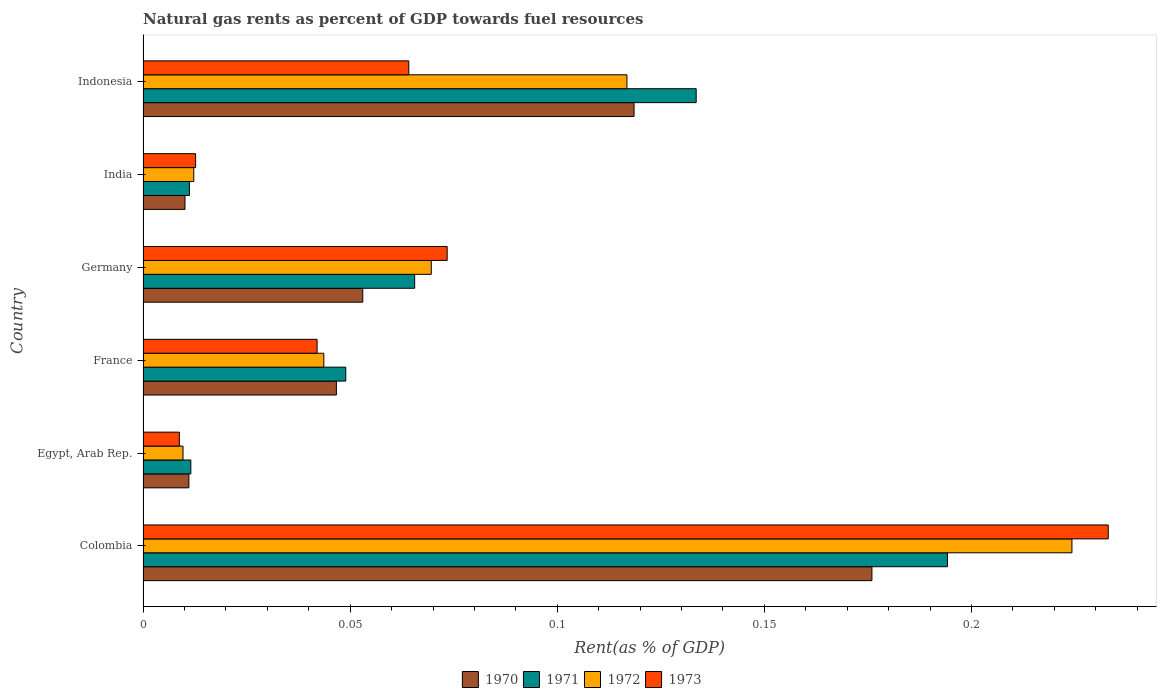How many different coloured bars are there?
Give a very brief answer. 4. Are the number of bars on each tick of the Y-axis equal?
Provide a short and direct response. Yes. How many bars are there on the 1st tick from the top?
Offer a terse response. 4. How many bars are there on the 3rd tick from the bottom?
Keep it short and to the point. 4. In how many cases, is the number of bars for a given country not equal to the number of legend labels?
Your response must be concise. 0. What is the matural gas rent in 1970 in Indonesia?
Your answer should be very brief. 0.12. Across all countries, what is the maximum matural gas rent in 1971?
Provide a succinct answer. 0.19. Across all countries, what is the minimum matural gas rent in 1971?
Ensure brevity in your answer.  0.01. In which country was the matural gas rent in 1972 maximum?
Provide a succinct answer. Colombia. In which country was the matural gas rent in 1970 minimum?
Give a very brief answer. India. What is the total matural gas rent in 1973 in the graph?
Your response must be concise. 0.43. What is the difference between the matural gas rent in 1973 in France and that in Indonesia?
Your answer should be very brief. -0.02. What is the difference between the matural gas rent in 1972 in Colombia and the matural gas rent in 1971 in France?
Ensure brevity in your answer.  0.18. What is the average matural gas rent in 1973 per country?
Ensure brevity in your answer.  0.07. What is the difference between the matural gas rent in 1971 and matural gas rent in 1973 in France?
Make the answer very short. 0.01. What is the ratio of the matural gas rent in 1972 in Germany to that in India?
Keep it short and to the point. 5.68. What is the difference between the highest and the second highest matural gas rent in 1972?
Ensure brevity in your answer.  0.11. What is the difference between the highest and the lowest matural gas rent in 1971?
Provide a succinct answer. 0.18. In how many countries, is the matural gas rent in 1970 greater than the average matural gas rent in 1970 taken over all countries?
Your answer should be compact. 2. Is the sum of the matural gas rent in 1971 in Germany and India greater than the maximum matural gas rent in 1973 across all countries?
Ensure brevity in your answer.  No. Is it the case that in every country, the sum of the matural gas rent in 1972 and matural gas rent in 1970 is greater than the sum of matural gas rent in 1973 and matural gas rent in 1971?
Offer a very short reply. No. Are all the bars in the graph horizontal?
Your response must be concise. Yes. What is the difference between two consecutive major ticks on the X-axis?
Make the answer very short. 0.05. Where does the legend appear in the graph?
Make the answer very short. Bottom center. How many legend labels are there?
Keep it short and to the point. 4. What is the title of the graph?
Make the answer very short. Natural gas rents as percent of GDP towards fuel resources. What is the label or title of the X-axis?
Offer a very short reply. Rent(as % of GDP). What is the label or title of the Y-axis?
Provide a succinct answer. Country. What is the Rent(as % of GDP) in 1970 in Colombia?
Keep it short and to the point. 0.18. What is the Rent(as % of GDP) in 1971 in Colombia?
Your answer should be compact. 0.19. What is the Rent(as % of GDP) in 1972 in Colombia?
Your answer should be very brief. 0.22. What is the Rent(as % of GDP) of 1973 in Colombia?
Provide a short and direct response. 0.23. What is the Rent(as % of GDP) of 1970 in Egypt, Arab Rep.?
Ensure brevity in your answer.  0.01. What is the Rent(as % of GDP) in 1971 in Egypt, Arab Rep.?
Give a very brief answer. 0.01. What is the Rent(as % of GDP) of 1972 in Egypt, Arab Rep.?
Your answer should be very brief. 0.01. What is the Rent(as % of GDP) in 1973 in Egypt, Arab Rep.?
Ensure brevity in your answer.  0.01. What is the Rent(as % of GDP) of 1970 in France?
Offer a terse response. 0.05. What is the Rent(as % of GDP) of 1971 in France?
Keep it short and to the point. 0.05. What is the Rent(as % of GDP) of 1972 in France?
Offer a terse response. 0.04. What is the Rent(as % of GDP) in 1973 in France?
Offer a very short reply. 0.04. What is the Rent(as % of GDP) in 1970 in Germany?
Offer a very short reply. 0.05. What is the Rent(as % of GDP) of 1971 in Germany?
Provide a short and direct response. 0.07. What is the Rent(as % of GDP) of 1972 in Germany?
Your response must be concise. 0.07. What is the Rent(as % of GDP) of 1973 in Germany?
Your answer should be very brief. 0.07. What is the Rent(as % of GDP) of 1970 in India?
Ensure brevity in your answer.  0.01. What is the Rent(as % of GDP) in 1971 in India?
Your answer should be compact. 0.01. What is the Rent(as % of GDP) of 1972 in India?
Your answer should be very brief. 0.01. What is the Rent(as % of GDP) of 1973 in India?
Your answer should be compact. 0.01. What is the Rent(as % of GDP) in 1970 in Indonesia?
Your response must be concise. 0.12. What is the Rent(as % of GDP) in 1971 in Indonesia?
Your answer should be compact. 0.13. What is the Rent(as % of GDP) in 1972 in Indonesia?
Ensure brevity in your answer.  0.12. What is the Rent(as % of GDP) of 1973 in Indonesia?
Make the answer very short. 0.06. Across all countries, what is the maximum Rent(as % of GDP) of 1970?
Your response must be concise. 0.18. Across all countries, what is the maximum Rent(as % of GDP) in 1971?
Offer a very short reply. 0.19. Across all countries, what is the maximum Rent(as % of GDP) in 1972?
Provide a short and direct response. 0.22. Across all countries, what is the maximum Rent(as % of GDP) in 1973?
Your answer should be very brief. 0.23. Across all countries, what is the minimum Rent(as % of GDP) in 1970?
Your answer should be compact. 0.01. Across all countries, what is the minimum Rent(as % of GDP) in 1971?
Offer a very short reply. 0.01. Across all countries, what is the minimum Rent(as % of GDP) of 1972?
Offer a terse response. 0.01. Across all countries, what is the minimum Rent(as % of GDP) in 1973?
Your response must be concise. 0.01. What is the total Rent(as % of GDP) of 1970 in the graph?
Keep it short and to the point. 0.42. What is the total Rent(as % of GDP) of 1971 in the graph?
Make the answer very short. 0.47. What is the total Rent(as % of GDP) in 1972 in the graph?
Make the answer very short. 0.48. What is the total Rent(as % of GDP) in 1973 in the graph?
Provide a short and direct response. 0.43. What is the difference between the Rent(as % of GDP) in 1970 in Colombia and that in Egypt, Arab Rep.?
Provide a short and direct response. 0.16. What is the difference between the Rent(as % of GDP) of 1971 in Colombia and that in Egypt, Arab Rep.?
Your answer should be very brief. 0.18. What is the difference between the Rent(as % of GDP) of 1972 in Colombia and that in Egypt, Arab Rep.?
Give a very brief answer. 0.21. What is the difference between the Rent(as % of GDP) in 1973 in Colombia and that in Egypt, Arab Rep.?
Your answer should be compact. 0.22. What is the difference between the Rent(as % of GDP) in 1970 in Colombia and that in France?
Give a very brief answer. 0.13. What is the difference between the Rent(as % of GDP) in 1971 in Colombia and that in France?
Your response must be concise. 0.15. What is the difference between the Rent(as % of GDP) of 1972 in Colombia and that in France?
Provide a succinct answer. 0.18. What is the difference between the Rent(as % of GDP) of 1973 in Colombia and that in France?
Provide a succinct answer. 0.19. What is the difference between the Rent(as % of GDP) in 1970 in Colombia and that in Germany?
Make the answer very short. 0.12. What is the difference between the Rent(as % of GDP) in 1971 in Colombia and that in Germany?
Offer a terse response. 0.13. What is the difference between the Rent(as % of GDP) of 1972 in Colombia and that in Germany?
Your response must be concise. 0.15. What is the difference between the Rent(as % of GDP) of 1973 in Colombia and that in Germany?
Make the answer very short. 0.16. What is the difference between the Rent(as % of GDP) of 1970 in Colombia and that in India?
Give a very brief answer. 0.17. What is the difference between the Rent(as % of GDP) in 1971 in Colombia and that in India?
Offer a very short reply. 0.18. What is the difference between the Rent(as % of GDP) of 1972 in Colombia and that in India?
Your answer should be compact. 0.21. What is the difference between the Rent(as % of GDP) of 1973 in Colombia and that in India?
Offer a very short reply. 0.22. What is the difference between the Rent(as % of GDP) of 1970 in Colombia and that in Indonesia?
Your answer should be compact. 0.06. What is the difference between the Rent(as % of GDP) of 1971 in Colombia and that in Indonesia?
Offer a very short reply. 0.06. What is the difference between the Rent(as % of GDP) of 1972 in Colombia and that in Indonesia?
Provide a succinct answer. 0.11. What is the difference between the Rent(as % of GDP) in 1973 in Colombia and that in Indonesia?
Keep it short and to the point. 0.17. What is the difference between the Rent(as % of GDP) in 1970 in Egypt, Arab Rep. and that in France?
Your answer should be very brief. -0.04. What is the difference between the Rent(as % of GDP) in 1971 in Egypt, Arab Rep. and that in France?
Your answer should be very brief. -0.04. What is the difference between the Rent(as % of GDP) in 1972 in Egypt, Arab Rep. and that in France?
Your answer should be very brief. -0.03. What is the difference between the Rent(as % of GDP) of 1973 in Egypt, Arab Rep. and that in France?
Offer a terse response. -0.03. What is the difference between the Rent(as % of GDP) in 1970 in Egypt, Arab Rep. and that in Germany?
Provide a succinct answer. -0.04. What is the difference between the Rent(as % of GDP) in 1971 in Egypt, Arab Rep. and that in Germany?
Your answer should be compact. -0.05. What is the difference between the Rent(as % of GDP) in 1972 in Egypt, Arab Rep. and that in Germany?
Ensure brevity in your answer.  -0.06. What is the difference between the Rent(as % of GDP) in 1973 in Egypt, Arab Rep. and that in Germany?
Provide a succinct answer. -0.06. What is the difference between the Rent(as % of GDP) in 1970 in Egypt, Arab Rep. and that in India?
Give a very brief answer. 0. What is the difference between the Rent(as % of GDP) in 1971 in Egypt, Arab Rep. and that in India?
Your answer should be very brief. 0. What is the difference between the Rent(as % of GDP) of 1972 in Egypt, Arab Rep. and that in India?
Provide a short and direct response. -0. What is the difference between the Rent(as % of GDP) in 1973 in Egypt, Arab Rep. and that in India?
Ensure brevity in your answer.  -0. What is the difference between the Rent(as % of GDP) of 1970 in Egypt, Arab Rep. and that in Indonesia?
Keep it short and to the point. -0.11. What is the difference between the Rent(as % of GDP) of 1971 in Egypt, Arab Rep. and that in Indonesia?
Offer a terse response. -0.12. What is the difference between the Rent(as % of GDP) of 1972 in Egypt, Arab Rep. and that in Indonesia?
Make the answer very short. -0.11. What is the difference between the Rent(as % of GDP) in 1973 in Egypt, Arab Rep. and that in Indonesia?
Offer a very short reply. -0.06. What is the difference between the Rent(as % of GDP) of 1970 in France and that in Germany?
Offer a very short reply. -0.01. What is the difference between the Rent(as % of GDP) in 1971 in France and that in Germany?
Provide a short and direct response. -0.02. What is the difference between the Rent(as % of GDP) in 1972 in France and that in Germany?
Provide a short and direct response. -0.03. What is the difference between the Rent(as % of GDP) of 1973 in France and that in Germany?
Keep it short and to the point. -0.03. What is the difference between the Rent(as % of GDP) in 1970 in France and that in India?
Offer a very short reply. 0.04. What is the difference between the Rent(as % of GDP) of 1971 in France and that in India?
Provide a succinct answer. 0.04. What is the difference between the Rent(as % of GDP) in 1972 in France and that in India?
Ensure brevity in your answer.  0.03. What is the difference between the Rent(as % of GDP) in 1973 in France and that in India?
Provide a succinct answer. 0.03. What is the difference between the Rent(as % of GDP) in 1970 in France and that in Indonesia?
Your answer should be very brief. -0.07. What is the difference between the Rent(as % of GDP) in 1971 in France and that in Indonesia?
Ensure brevity in your answer.  -0.08. What is the difference between the Rent(as % of GDP) of 1972 in France and that in Indonesia?
Your response must be concise. -0.07. What is the difference between the Rent(as % of GDP) in 1973 in France and that in Indonesia?
Keep it short and to the point. -0.02. What is the difference between the Rent(as % of GDP) in 1970 in Germany and that in India?
Give a very brief answer. 0.04. What is the difference between the Rent(as % of GDP) of 1971 in Germany and that in India?
Give a very brief answer. 0.05. What is the difference between the Rent(as % of GDP) in 1972 in Germany and that in India?
Your response must be concise. 0.06. What is the difference between the Rent(as % of GDP) of 1973 in Germany and that in India?
Your response must be concise. 0.06. What is the difference between the Rent(as % of GDP) in 1970 in Germany and that in Indonesia?
Offer a terse response. -0.07. What is the difference between the Rent(as % of GDP) of 1971 in Germany and that in Indonesia?
Offer a very short reply. -0.07. What is the difference between the Rent(as % of GDP) in 1972 in Germany and that in Indonesia?
Ensure brevity in your answer.  -0.05. What is the difference between the Rent(as % of GDP) of 1973 in Germany and that in Indonesia?
Provide a succinct answer. 0.01. What is the difference between the Rent(as % of GDP) in 1970 in India and that in Indonesia?
Offer a terse response. -0.11. What is the difference between the Rent(as % of GDP) of 1971 in India and that in Indonesia?
Ensure brevity in your answer.  -0.12. What is the difference between the Rent(as % of GDP) in 1972 in India and that in Indonesia?
Provide a succinct answer. -0.1. What is the difference between the Rent(as % of GDP) of 1973 in India and that in Indonesia?
Your answer should be very brief. -0.05. What is the difference between the Rent(as % of GDP) in 1970 in Colombia and the Rent(as % of GDP) in 1971 in Egypt, Arab Rep.?
Offer a terse response. 0.16. What is the difference between the Rent(as % of GDP) in 1970 in Colombia and the Rent(as % of GDP) in 1972 in Egypt, Arab Rep.?
Make the answer very short. 0.17. What is the difference between the Rent(as % of GDP) in 1970 in Colombia and the Rent(as % of GDP) in 1973 in Egypt, Arab Rep.?
Provide a succinct answer. 0.17. What is the difference between the Rent(as % of GDP) in 1971 in Colombia and the Rent(as % of GDP) in 1972 in Egypt, Arab Rep.?
Offer a terse response. 0.18. What is the difference between the Rent(as % of GDP) in 1971 in Colombia and the Rent(as % of GDP) in 1973 in Egypt, Arab Rep.?
Keep it short and to the point. 0.19. What is the difference between the Rent(as % of GDP) in 1972 in Colombia and the Rent(as % of GDP) in 1973 in Egypt, Arab Rep.?
Your response must be concise. 0.22. What is the difference between the Rent(as % of GDP) of 1970 in Colombia and the Rent(as % of GDP) of 1971 in France?
Provide a short and direct response. 0.13. What is the difference between the Rent(as % of GDP) in 1970 in Colombia and the Rent(as % of GDP) in 1972 in France?
Ensure brevity in your answer.  0.13. What is the difference between the Rent(as % of GDP) in 1970 in Colombia and the Rent(as % of GDP) in 1973 in France?
Provide a succinct answer. 0.13. What is the difference between the Rent(as % of GDP) of 1971 in Colombia and the Rent(as % of GDP) of 1972 in France?
Your answer should be compact. 0.15. What is the difference between the Rent(as % of GDP) of 1971 in Colombia and the Rent(as % of GDP) of 1973 in France?
Offer a very short reply. 0.15. What is the difference between the Rent(as % of GDP) of 1972 in Colombia and the Rent(as % of GDP) of 1973 in France?
Give a very brief answer. 0.18. What is the difference between the Rent(as % of GDP) in 1970 in Colombia and the Rent(as % of GDP) in 1971 in Germany?
Provide a succinct answer. 0.11. What is the difference between the Rent(as % of GDP) in 1970 in Colombia and the Rent(as % of GDP) in 1972 in Germany?
Keep it short and to the point. 0.11. What is the difference between the Rent(as % of GDP) of 1970 in Colombia and the Rent(as % of GDP) of 1973 in Germany?
Ensure brevity in your answer.  0.1. What is the difference between the Rent(as % of GDP) of 1971 in Colombia and the Rent(as % of GDP) of 1972 in Germany?
Offer a very short reply. 0.12. What is the difference between the Rent(as % of GDP) of 1971 in Colombia and the Rent(as % of GDP) of 1973 in Germany?
Ensure brevity in your answer.  0.12. What is the difference between the Rent(as % of GDP) of 1972 in Colombia and the Rent(as % of GDP) of 1973 in Germany?
Provide a short and direct response. 0.15. What is the difference between the Rent(as % of GDP) in 1970 in Colombia and the Rent(as % of GDP) in 1971 in India?
Provide a short and direct response. 0.16. What is the difference between the Rent(as % of GDP) of 1970 in Colombia and the Rent(as % of GDP) of 1972 in India?
Ensure brevity in your answer.  0.16. What is the difference between the Rent(as % of GDP) of 1970 in Colombia and the Rent(as % of GDP) of 1973 in India?
Make the answer very short. 0.16. What is the difference between the Rent(as % of GDP) of 1971 in Colombia and the Rent(as % of GDP) of 1972 in India?
Give a very brief answer. 0.18. What is the difference between the Rent(as % of GDP) of 1971 in Colombia and the Rent(as % of GDP) of 1973 in India?
Provide a short and direct response. 0.18. What is the difference between the Rent(as % of GDP) of 1972 in Colombia and the Rent(as % of GDP) of 1973 in India?
Your answer should be very brief. 0.21. What is the difference between the Rent(as % of GDP) of 1970 in Colombia and the Rent(as % of GDP) of 1971 in Indonesia?
Ensure brevity in your answer.  0.04. What is the difference between the Rent(as % of GDP) of 1970 in Colombia and the Rent(as % of GDP) of 1972 in Indonesia?
Offer a terse response. 0.06. What is the difference between the Rent(as % of GDP) in 1970 in Colombia and the Rent(as % of GDP) in 1973 in Indonesia?
Make the answer very short. 0.11. What is the difference between the Rent(as % of GDP) of 1971 in Colombia and the Rent(as % of GDP) of 1972 in Indonesia?
Offer a very short reply. 0.08. What is the difference between the Rent(as % of GDP) of 1971 in Colombia and the Rent(as % of GDP) of 1973 in Indonesia?
Keep it short and to the point. 0.13. What is the difference between the Rent(as % of GDP) in 1972 in Colombia and the Rent(as % of GDP) in 1973 in Indonesia?
Your response must be concise. 0.16. What is the difference between the Rent(as % of GDP) of 1970 in Egypt, Arab Rep. and the Rent(as % of GDP) of 1971 in France?
Provide a succinct answer. -0.04. What is the difference between the Rent(as % of GDP) in 1970 in Egypt, Arab Rep. and the Rent(as % of GDP) in 1972 in France?
Your answer should be very brief. -0.03. What is the difference between the Rent(as % of GDP) in 1970 in Egypt, Arab Rep. and the Rent(as % of GDP) in 1973 in France?
Keep it short and to the point. -0.03. What is the difference between the Rent(as % of GDP) of 1971 in Egypt, Arab Rep. and the Rent(as % of GDP) of 1972 in France?
Your answer should be very brief. -0.03. What is the difference between the Rent(as % of GDP) in 1971 in Egypt, Arab Rep. and the Rent(as % of GDP) in 1973 in France?
Ensure brevity in your answer.  -0.03. What is the difference between the Rent(as % of GDP) in 1972 in Egypt, Arab Rep. and the Rent(as % of GDP) in 1973 in France?
Provide a short and direct response. -0.03. What is the difference between the Rent(as % of GDP) of 1970 in Egypt, Arab Rep. and the Rent(as % of GDP) of 1971 in Germany?
Provide a short and direct response. -0.05. What is the difference between the Rent(as % of GDP) of 1970 in Egypt, Arab Rep. and the Rent(as % of GDP) of 1972 in Germany?
Provide a short and direct response. -0.06. What is the difference between the Rent(as % of GDP) in 1970 in Egypt, Arab Rep. and the Rent(as % of GDP) in 1973 in Germany?
Your response must be concise. -0.06. What is the difference between the Rent(as % of GDP) of 1971 in Egypt, Arab Rep. and the Rent(as % of GDP) of 1972 in Germany?
Make the answer very short. -0.06. What is the difference between the Rent(as % of GDP) in 1971 in Egypt, Arab Rep. and the Rent(as % of GDP) in 1973 in Germany?
Offer a terse response. -0.06. What is the difference between the Rent(as % of GDP) in 1972 in Egypt, Arab Rep. and the Rent(as % of GDP) in 1973 in Germany?
Give a very brief answer. -0.06. What is the difference between the Rent(as % of GDP) of 1970 in Egypt, Arab Rep. and the Rent(as % of GDP) of 1971 in India?
Give a very brief answer. -0. What is the difference between the Rent(as % of GDP) in 1970 in Egypt, Arab Rep. and the Rent(as % of GDP) in 1972 in India?
Make the answer very short. -0. What is the difference between the Rent(as % of GDP) in 1970 in Egypt, Arab Rep. and the Rent(as % of GDP) in 1973 in India?
Offer a terse response. -0. What is the difference between the Rent(as % of GDP) of 1971 in Egypt, Arab Rep. and the Rent(as % of GDP) of 1972 in India?
Your response must be concise. -0. What is the difference between the Rent(as % of GDP) of 1971 in Egypt, Arab Rep. and the Rent(as % of GDP) of 1973 in India?
Provide a succinct answer. -0. What is the difference between the Rent(as % of GDP) in 1972 in Egypt, Arab Rep. and the Rent(as % of GDP) in 1973 in India?
Your answer should be very brief. -0. What is the difference between the Rent(as % of GDP) of 1970 in Egypt, Arab Rep. and the Rent(as % of GDP) of 1971 in Indonesia?
Your answer should be very brief. -0.12. What is the difference between the Rent(as % of GDP) in 1970 in Egypt, Arab Rep. and the Rent(as % of GDP) in 1972 in Indonesia?
Offer a very short reply. -0.11. What is the difference between the Rent(as % of GDP) in 1970 in Egypt, Arab Rep. and the Rent(as % of GDP) in 1973 in Indonesia?
Your answer should be very brief. -0.05. What is the difference between the Rent(as % of GDP) of 1971 in Egypt, Arab Rep. and the Rent(as % of GDP) of 1972 in Indonesia?
Your answer should be very brief. -0.11. What is the difference between the Rent(as % of GDP) in 1971 in Egypt, Arab Rep. and the Rent(as % of GDP) in 1973 in Indonesia?
Give a very brief answer. -0.05. What is the difference between the Rent(as % of GDP) in 1972 in Egypt, Arab Rep. and the Rent(as % of GDP) in 1973 in Indonesia?
Provide a short and direct response. -0.05. What is the difference between the Rent(as % of GDP) in 1970 in France and the Rent(as % of GDP) in 1971 in Germany?
Keep it short and to the point. -0.02. What is the difference between the Rent(as % of GDP) in 1970 in France and the Rent(as % of GDP) in 1972 in Germany?
Your answer should be very brief. -0.02. What is the difference between the Rent(as % of GDP) of 1970 in France and the Rent(as % of GDP) of 1973 in Germany?
Your answer should be very brief. -0.03. What is the difference between the Rent(as % of GDP) in 1971 in France and the Rent(as % of GDP) in 1972 in Germany?
Your answer should be compact. -0.02. What is the difference between the Rent(as % of GDP) in 1971 in France and the Rent(as % of GDP) in 1973 in Germany?
Provide a short and direct response. -0.02. What is the difference between the Rent(as % of GDP) in 1972 in France and the Rent(as % of GDP) in 1973 in Germany?
Your response must be concise. -0.03. What is the difference between the Rent(as % of GDP) of 1970 in France and the Rent(as % of GDP) of 1971 in India?
Provide a short and direct response. 0.04. What is the difference between the Rent(as % of GDP) of 1970 in France and the Rent(as % of GDP) of 1972 in India?
Give a very brief answer. 0.03. What is the difference between the Rent(as % of GDP) in 1970 in France and the Rent(as % of GDP) in 1973 in India?
Provide a short and direct response. 0.03. What is the difference between the Rent(as % of GDP) of 1971 in France and the Rent(as % of GDP) of 1972 in India?
Make the answer very short. 0.04. What is the difference between the Rent(as % of GDP) of 1971 in France and the Rent(as % of GDP) of 1973 in India?
Give a very brief answer. 0.04. What is the difference between the Rent(as % of GDP) in 1972 in France and the Rent(as % of GDP) in 1973 in India?
Your answer should be compact. 0.03. What is the difference between the Rent(as % of GDP) of 1970 in France and the Rent(as % of GDP) of 1971 in Indonesia?
Your answer should be very brief. -0.09. What is the difference between the Rent(as % of GDP) of 1970 in France and the Rent(as % of GDP) of 1972 in Indonesia?
Make the answer very short. -0.07. What is the difference between the Rent(as % of GDP) of 1970 in France and the Rent(as % of GDP) of 1973 in Indonesia?
Keep it short and to the point. -0.02. What is the difference between the Rent(as % of GDP) in 1971 in France and the Rent(as % of GDP) in 1972 in Indonesia?
Provide a succinct answer. -0.07. What is the difference between the Rent(as % of GDP) of 1971 in France and the Rent(as % of GDP) of 1973 in Indonesia?
Ensure brevity in your answer.  -0.02. What is the difference between the Rent(as % of GDP) of 1972 in France and the Rent(as % of GDP) of 1973 in Indonesia?
Provide a succinct answer. -0.02. What is the difference between the Rent(as % of GDP) of 1970 in Germany and the Rent(as % of GDP) of 1971 in India?
Give a very brief answer. 0.04. What is the difference between the Rent(as % of GDP) in 1970 in Germany and the Rent(as % of GDP) in 1972 in India?
Your answer should be very brief. 0.04. What is the difference between the Rent(as % of GDP) in 1970 in Germany and the Rent(as % of GDP) in 1973 in India?
Offer a terse response. 0.04. What is the difference between the Rent(as % of GDP) of 1971 in Germany and the Rent(as % of GDP) of 1972 in India?
Provide a short and direct response. 0.05. What is the difference between the Rent(as % of GDP) in 1971 in Germany and the Rent(as % of GDP) in 1973 in India?
Your response must be concise. 0.05. What is the difference between the Rent(as % of GDP) of 1972 in Germany and the Rent(as % of GDP) of 1973 in India?
Make the answer very short. 0.06. What is the difference between the Rent(as % of GDP) in 1970 in Germany and the Rent(as % of GDP) in 1971 in Indonesia?
Provide a short and direct response. -0.08. What is the difference between the Rent(as % of GDP) in 1970 in Germany and the Rent(as % of GDP) in 1972 in Indonesia?
Your response must be concise. -0.06. What is the difference between the Rent(as % of GDP) of 1970 in Germany and the Rent(as % of GDP) of 1973 in Indonesia?
Keep it short and to the point. -0.01. What is the difference between the Rent(as % of GDP) of 1971 in Germany and the Rent(as % of GDP) of 1972 in Indonesia?
Give a very brief answer. -0.05. What is the difference between the Rent(as % of GDP) of 1971 in Germany and the Rent(as % of GDP) of 1973 in Indonesia?
Make the answer very short. 0. What is the difference between the Rent(as % of GDP) of 1972 in Germany and the Rent(as % of GDP) of 1973 in Indonesia?
Your answer should be very brief. 0.01. What is the difference between the Rent(as % of GDP) in 1970 in India and the Rent(as % of GDP) in 1971 in Indonesia?
Ensure brevity in your answer.  -0.12. What is the difference between the Rent(as % of GDP) in 1970 in India and the Rent(as % of GDP) in 1972 in Indonesia?
Make the answer very short. -0.11. What is the difference between the Rent(as % of GDP) of 1970 in India and the Rent(as % of GDP) of 1973 in Indonesia?
Make the answer very short. -0.05. What is the difference between the Rent(as % of GDP) of 1971 in India and the Rent(as % of GDP) of 1972 in Indonesia?
Offer a terse response. -0.11. What is the difference between the Rent(as % of GDP) of 1971 in India and the Rent(as % of GDP) of 1973 in Indonesia?
Your answer should be compact. -0.05. What is the difference between the Rent(as % of GDP) of 1972 in India and the Rent(as % of GDP) of 1973 in Indonesia?
Provide a succinct answer. -0.05. What is the average Rent(as % of GDP) in 1970 per country?
Your answer should be very brief. 0.07. What is the average Rent(as % of GDP) of 1971 per country?
Provide a succinct answer. 0.08. What is the average Rent(as % of GDP) in 1972 per country?
Provide a succinct answer. 0.08. What is the average Rent(as % of GDP) of 1973 per country?
Make the answer very short. 0.07. What is the difference between the Rent(as % of GDP) in 1970 and Rent(as % of GDP) in 1971 in Colombia?
Offer a terse response. -0.02. What is the difference between the Rent(as % of GDP) in 1970 and Rent(as % of GDP) in 1972 in Colombia?
Give a very brief answer. -0.05. What is the difference between the Rent(as % of GDP) in 1970 and Rent(as % of GDP) in 1973 in Colombia?
Your answer should be very brief. -0.06. What is the difference between the Rent(as % of GDP) of 1971 and Rent(as % of GDP) of 1972 in Colombia?
Make the answer very short. -0.03. What is the difference between the Rent(as % of GDP) of 1971 and Rent(as % of GDP) of 1973 in Colombia?
Keep it short and to the point. -0.04. What is the difference between the Rent(as % of GDP) in 1972 and Rent(as % of GDP) in 1973 in Colombia?
Your response must be concise. -0.01. What is the difference between the Rent(as % of GDP) of 1970 and Rent(as % of GDP) of 1971 in Egypt, Arab Rep.?
Make the answer very short. -0. What is the difference between the Rent(as % of GDP) of 1970 and Rent(as % of GDP) of 1972 in Egypt, Arab Rep.?
Make the answer very short. 0. What is the difference between the Rent(as % of GDP) of 1970 and Rent(as % of GDP) of 1973 in Egypt, Arab Rep.?
Your answer should be compact. 0. What is the difference between the Rent(as % of GDP) in 1971 and Rent(as % of GDP) in 1972 in Egypt, Arab Rep.?
Make the answer very short. 0. What is the difference between the Rent(as % of GDP) of 1971 and Rent(as % of GDP) of 1973 in Egypt, Arab Rep.?
Make the answer very short. 0. What is the difference between the Rent(as % of GDP) of 1972 and Rent(as % of GDP) of 1973 in Egypt, Arab Rep.?
Keep it short and to the point. 0. What is the difference between the Rent(as % of GDP) of 1970 and Rent(as % of GDP) of 1971 in France?
Provide a short and direct response. -0. What is the difference between the Rent(as % of GDP) in 1970 and Rent(as % of GDP) in 1972 in France?
Offer a terse response. 0. What is the difference between the Rent(as % of GDP) in 1970 and Rent(as % of GDP) in 1973 in France?
Keep it short and to the point. 0. What is the difference between the Rent(as % of GDP) of 1971 and Rent(as % of GDP) of 1972 in France?
Offer a very short reply. 0.01. What is the difference between the Rent(as % of GDP) in 1971 and Rent(as % of GDP) in 1973 in France?
Offer a terse response. 0.01. What is the difference between the Rent(as % of GDP) of 1972 and Rent(as % of GDP) of 1973 in France?
Offer a terse response. 0. What is the difference between the Rent(as % of GDP) in 1970 and Rent(as % of GDP) in 1971 in Germany?
Offer a terse response. -0.01. What is the difference between the Rent(as % of GDP) in 1970 and Rent(as % of GDP) in 1972 in Germany?
Provide a succinct answer. -0.02. What is the difference between the Rent(as % of GDP) of 1970 and Rent(as % of GDP) of 1973 in Germany?
Give a very brief answer. -0.02. What is the difference between the Rent(as % of GDP) in 1971 and Rent(as % of GDP) in 1972 in Germany?
Offer a very short reply. -0. What is the difference between the Rent(as % of GDP) in 1971 and Rent(as % of GDP) in 1973 in Germany?
Make the answer very short. -0.01. What is the difference between the Rent(as % of GDP) in 1972 and Rent(as % of GDP) in 1973 in Germany?
Keep it short and to the point. -0. What is the difference between the Rent(as % of GDP) of 1970 and Rent(as % of GDP) of 1971 in India?
Your answer should be compact. -0. What is the difference between the Rent(as % of GDP) of 1970 and Rent(as % of GDP) of 1972 in India?
Ensure brevity in your answer.  -0. What is the difference between the Rent(as % of GDP) of 1970 and Rent(as % of GDP) of 1973 in India?
Ensure brevity in your answer.  -0. What is the difference between the Rent(as % of GDP) in 1971 and Rent(as % of GDP) in 1972 in India?
Offer a very short reply. -0. What is the difference between the Rent(as % of GDP) in 1971 and Rent(as % of GDP) in 1973 in India?
Offer a very short reply. -0. What is the difference between the Rent(as % of GDP) in 1972 and Rent(as % of GDP) in 1973 in India?
Your answer should be compact. -0. What is the difference between the Rent(as % of GDP) of 1970 and Rent(as % of GDP) of 1971 in Indonesia?
Ensure brevity in your answer.  -0.01. What is the difference between the Rent(as % of GDP) of 1970 and Rent(as % of GDP) of 1972 in Indonesia?
Offer a very short reply. 0. What is the difference between the Rent(as % of GDP) of 1970 and Rent(as % of GDP) of 1973 in Indonesia?
Your response must be concise. 0.05. What is the difference between the Rent(as % of GDP) in 1971 and Rent(as % of GDP) in 1972 in Indonesia?
Your answer should be very brief. 0.02. What is the difference between the Rent(as % of GDP) of 1971 and Rent(as % of GDP) of 1973 in Indonesia?
Keep it short and to the point. 0.07. What is the difference between the Rent(as % of GDP) in 1972 and Rent(as % of GDP) in 1973 in Indonesia?
Your answer should be compact. 0.05. What is the ratio of the Rent(as % of GDP) in 1970 in Colombia to that in Egypt, Arab Rep.?
Provide a succinct answer. 15.9. What is the ratio of the Rent(as % of GDP) of 1971 in Colombia to that in Egypt, Arab Rep.?
Ensure brevity in your answer.  16.84. What is the ratio of the Rent(as % of GDP) of 1972 in Colombia to that in Egypt, Arab Rep.?
Give a very brief answer. 23.25. What is the ratio of the Rent(as % of GDP) in 1973 in Colombia to that in Egypt, Arab Rep.?
Your answer should be very brief. 26.6. What is the ratio of the Rent(as % of GDP) of 1970 in Colombia to that in France?
Make the answer very short. 3.77. What is the ratio of the Rent(as % of GDP) of 1971 in Colombia to that in France?
Ensure brevity in your answer.  3.97. What is the ratio of the Rent(as % of GDP) in 1972 in Colombia to that in France?
Your answer should be very brief. 5.14. What is the ratio of the Rent(as % of GDP) of 1973 in Colombia to that in France?
Your answer should be very brief. 5.55. What is the ratio of the Rent(as % of GDP) of 1970 in Colombia to that in Germany?
Offer a terse response. 3.32. What is the ratio of the Rent(as % of GDP) of 1971 in Colombia to that in Germany?
Give a very brief answer. 2.96. What is the ratio of the Rent(as % of GDP) of 1972 in Colombia to that in Germany?
Provide a short and direct response. 3.22. What is the ratio of the Rent(as % of GDP) in 1973 in Colombia to that in Germany?
Your answer should be very brief. 3.17. What is the ratio of the Rent(as % of GDP) in 1970 in Colombia to that in India?
Your answer should be very brief. 17.38. What is the ratio of the Rent(as % of GDP) of 1971 in Colombia to that in India?
Keep it short and to the point. 17.35. What is the ratio of the Rent(as % of GDP) of 1972 in Colombia to that in India?
Give a very brief answer. 18.31. What is the ratio of the Rent(as % of GDP) of 1973 in Colombia to that in India?
Your response must be concise. 18.36. What is the ratio of the Rent(as % of GDP) in 1970 in Colombia to that in Indonesia?
Your answer should be compact. 1.48. What is the ratio of the Rent(as % of GDP) in 1971 in Colombia to that in Indonesia?
Provide a succinct answer. 1.45. What is the ratio of the Rent(as % of GDP) in 1972 in Colombia to that in Indonesia?
Ensure brevity in your answer.  1.92. What is the ratio of the Rent(as % of GDP) in 1973 in Colombia to that in Indonesia?
Provide a succinct answer. 3.63. What is the ratio of the Rent(as % of GDP) of 1970 in Egypt, Arab Rep. to that in France?
Offer a very short reply. 0.24. What is the ratio of the Rent(as % of GDP) of 1971 in Egypt, Arab Rep. to that in France?
Provide a short and direct response. 0.24. What is the ratio of the Rent(as % of GDP) in 1972 in Egypt, Arab Rep. to that in France?
Keep it short and to the point. 0.22. What is the ratio of the Rent(as % of GDP) in 1973 in Egypt, Arab Rep. to that in France?
Offer a very short reply. 0.21. What is the ratio of the Rent(as % of GDP) in 1970 in Egypt, Arab Rep. to that in Germany?
Provide a short and direct response. 0.21. What is the ratio of the Rent(as % of GDP) of 1971 in Egypt, Arab Rep. to that in Germany?
Keep it short and to the point. 0.18. What is the ratio of the Rent(as % of GDP) of 1972 in Egypt, Arab Rep. to that in Germany?
Provide a succinct answer. 0.14. What is the ratio of the Rent(as % of GDP) of 1973 in Egypt, Arab Rep. to that in Germany?
Your answer should be very brief. 0.12. What is the ratio of the Rent(as % of GDP) in 1970 in Egypt, Arab Rep. to that in India?
Ensure brevity in your answer.  1.09. What is the ratio of the Rent(as % of GDP) in 1971 in Egypt, Arab Rep. to that in India?
Your answer should be very brief. 1.03. What is the ratio of the Rent(as % of GDP) in 1972 in Egypt, Arab Rep. to that in India?
Provide a succinct answer. 0.79. What is the ratio of the Rent(as % of GDP) of 1973 in Egypt, Arab Rep. to that in India?
Offer a very short reply. 0.69. What is the ratio of the Rent(as % of GDP) of 1970 in Egypt, Arab Rep. to that in Indonesia?
Your response must be concise. 0.09. What is the ratio of the Rent(as % of GDP) in 1971 in Egypt, Arab Rep. to that in Indonesia?
Offer a terse response. 0.09. What is the ratio of the Rent(as % of GDP) in 1972 in Egypt, Arab Rep. to that in Indonesia?
Your answer should be compact. 0.08. What is the ratio of the Rent(as % of GDP) of 1973 in Egypt, Arab Rep. to that in Indonesia?
Ensure brevity in your answer.  0.14. What is the ratio of the Rent(as % of GDP) of 1970 in France to that in Germany?
Your answer should be compact. 0.88. What is the ratio of the Rent(as % of GDP) of 1971 in France to that in Germany?
Your answer should be compact. 0.75. What is the ratio of the Rent(as % of GDP) in 1972 in France to that in Germany?
Your answer should be compact. 0.63. What is the ratio of the Rent(as % of GDP) of 1973 in France to that in Germany?
Provide a succinct answer. 0.57. What is the ratio of the Rent(as % of GDP) in 1970 in France to that in India?
Offer a very short reply. 4.61. What is the ratio of the Rent(as % of GDP) in 1971 in France to that in India?
Offer a terse response. 4.37. What is the ratio of the Rent(as % of GDP) in 1972 in France to that in India?
Give a very brief answer. 3.56. What is the ratio of the Rent(as % of GDP) in 1973 in France to that in India?
Give a very brief answer. 3.31. What is the ratio of the Rent(as % of GDP) of 1970 in France to that in Indonesia?
Ensure brevity in your answer.  0.39. What is the ratio of the Rent(as % of GDP) of 1971 in France to that in Indonesia?
Provide a succinct answer. 0.37. What is the ratio of the Rent(as % of GDP) in 1972 in France to that in Indonesia?
Your answer should be compact. 0.37. What is the ratio of the Rent(as % of GDP) in 1973 in France to that in Indonesia?
Offer a very short reply. 0.65. What is the ratio of the Rent(as % of GDP) of 1970 in Germany to that in India?
Ensure brevity in your answer.  5.24. What is the ratio of the Rent(as % of GDP) of 1971 in Germany to that in India?
Offer a terse response. 5.86. What is the ratio of the Rent(as % of GDP) in 1972 in Germany to that in India?
Your answer should be very brief. 5.68. What is the ratio of the Rent(as % of GDP) of 1973 in Germany to that in India?
Offer a terse response. 5.79. What is the ratio of the Rent(as % of GDP) in 1970 in Germany to that in Indonesia?
Your answer should be compact. 0.45. What is the ratio of the Rent(as % of GDP) of 1971 in Germany to that in Indonesia?
Ensure brevity in your answer.  0.49. What is the ratio of the Rent(as % of GDP) of 1972 in Germany to that in Indonesia?
Offer a very short reply. 0.6. What is the ratio of the Rent(as % of GDP) of 1973 in Germany to that in Indonesia?
Offer a terse response. 1.14. What is the ratio of the Rent(as % of GDP) of 1970 in India to that in Indonesia?
Provide a succinct answer. 0.09. What is the ratio of the Rent(as % of GDP) of 1971 in India to that in Indonesia?
Give a very brief answer. 0.08. What is the ratio of the Rent(as % of GDP) of 1972 in India to that in Indonesia?
Give a very brief answer. 0.1. What is the ratio of the Rent(as % of GDP) of 1973 in India to that in Indonesia?
Your answer should be very brief. 0.2. What is the difference between the highest and the second highest Rent(as % of GDP) in 1970?
Your response must be concise. 0.06. What is the difference between the highest and the second highest Rent(as % of GDP) in 1971?
Provide a succinct answer. 0.06. What is the difference between the highest and the second highest Rent(as % of GDP) in 1972?
Your response must be concise. 0.11. What is the difference between the highest and the second highest Rent(as % of GDP) of 1973?
Your response must be concise. 0.16. What is the difference between the highest and the lowest Rent(as % of GDP) of 1970?
Your answer should be very brief. 0.17. What is the difference between the highest and the lowest Rent(as % of GDP) in 1971?
Keep it short and to the point. 0.18. What is the difference between the highest and the lowest Rent(as % of GDP) in 1972?
Your response must be concise. 0.21. What is the difference between the highest and the lowest Rent(as % of GDP) in 1973?
Provide a short and direct response. 0.22. 